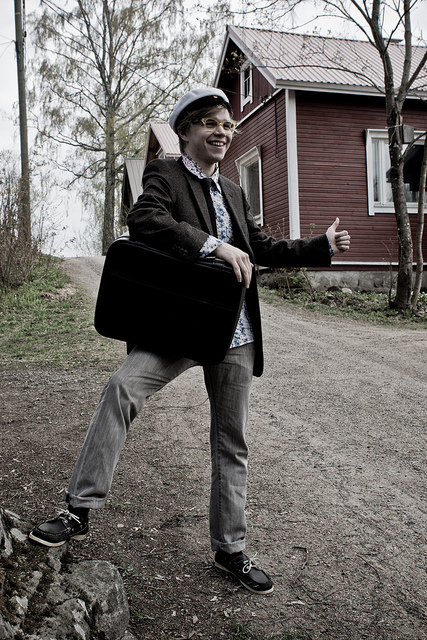<image>What pattern is on the boy's shirt? I don't know what pattern is on the boy's shirt. It can be checkered, solid, floral or plaid. What pattern is on the boy's shirt? I don't know what pattern is on the boy's shirt. It can be seen 'checkered', 'solid', 'floral', 'plaid' or none. 